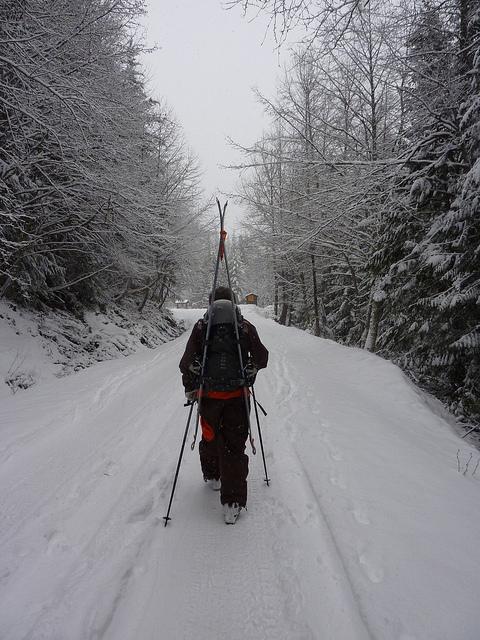How many backpacks are visible?
Give a very brief answer. 1. How many skateboards are in this scene?
Give a very brief answer. 0. 